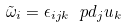Convert formula to latex. <formula><loc_0><loc_0><loc_500><loc_500>\tilde { \omega } _ { i } = \epsilon _ { i j k } \ p d _ { j } u _ { k }</formula> 